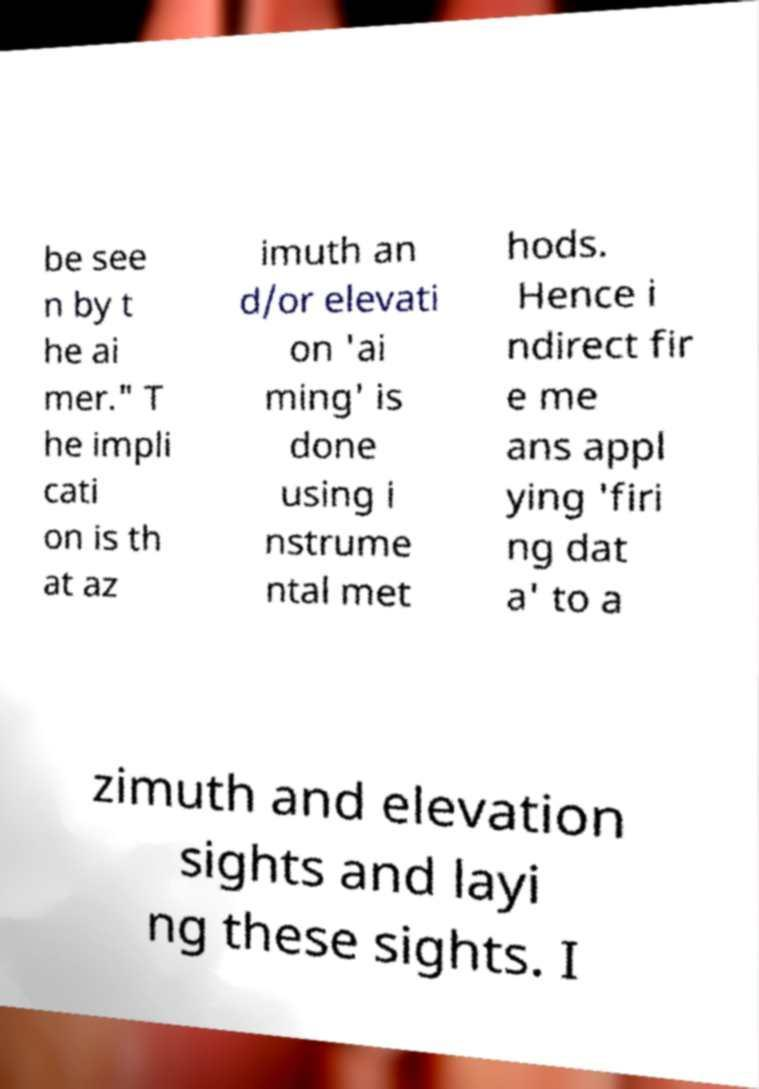Please identify and transcribe the text found in this image. be see n by t he ai mer." T he impli cati on is th at az imuth an d/or elevati on 'ai ming' is done using i nstrume ntal met hods. Hence i ndirect fir e me ans appl ying 'firi ng dat a' to a zimuth and elevation sights and layi ng these sights. I 